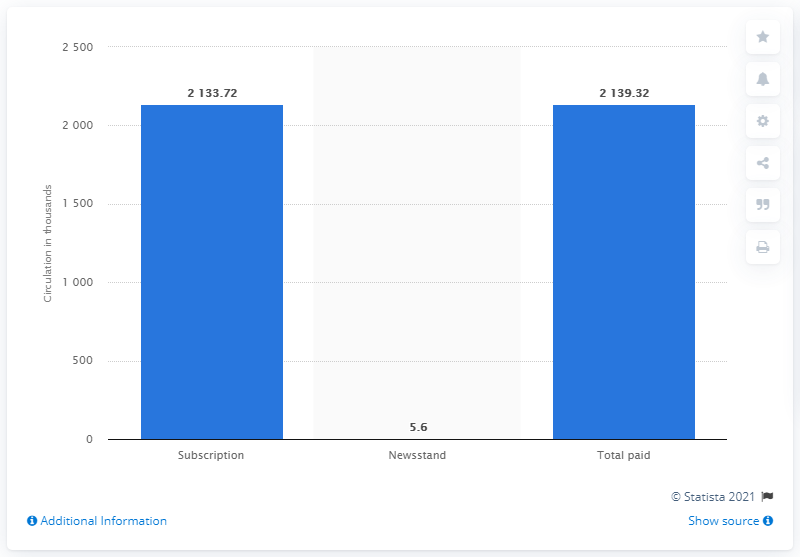List a handful of essential elements in this visual. In the first half of 2015, ESPN Magazine had a total paid circulation of 2133.72. ESPN sold 5.6 copies of its magazine at newsstands in the first half of 2015. In the first half of 2015, ESPN Magazine sold a total of 2,133.72 copies. 